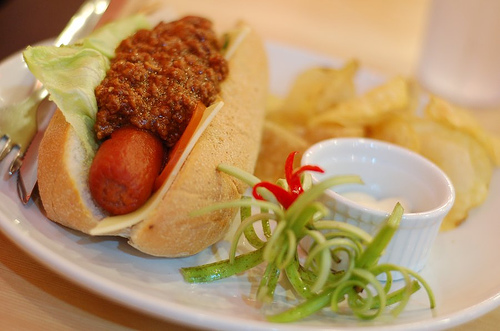<image>What is the green vegetable? I am not sure what the green vegetable is. It could be lettuce, celery, or onion. What is the green vegetable? I don't know what the green vegetable is. It can be scallion, lettuce, celery, or onion. 